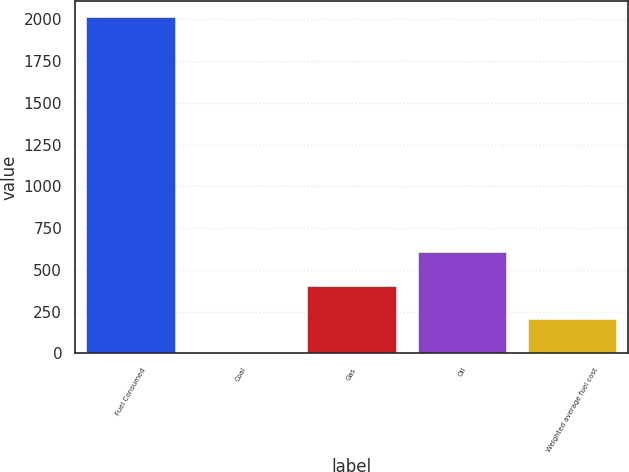Convert chart. <chart><loc_0><loc_0><loc_500><loc_500><bar_chart><fcel>Fuel Consumed<fcel>Coal<fcel>Gas<fcel>Oil<fcel>Weighted average fuel cost<nl><fcel>2013<fcel>2.9<fcel>404.92<fcel>605.93<fcel>203.91<nl></chart> 